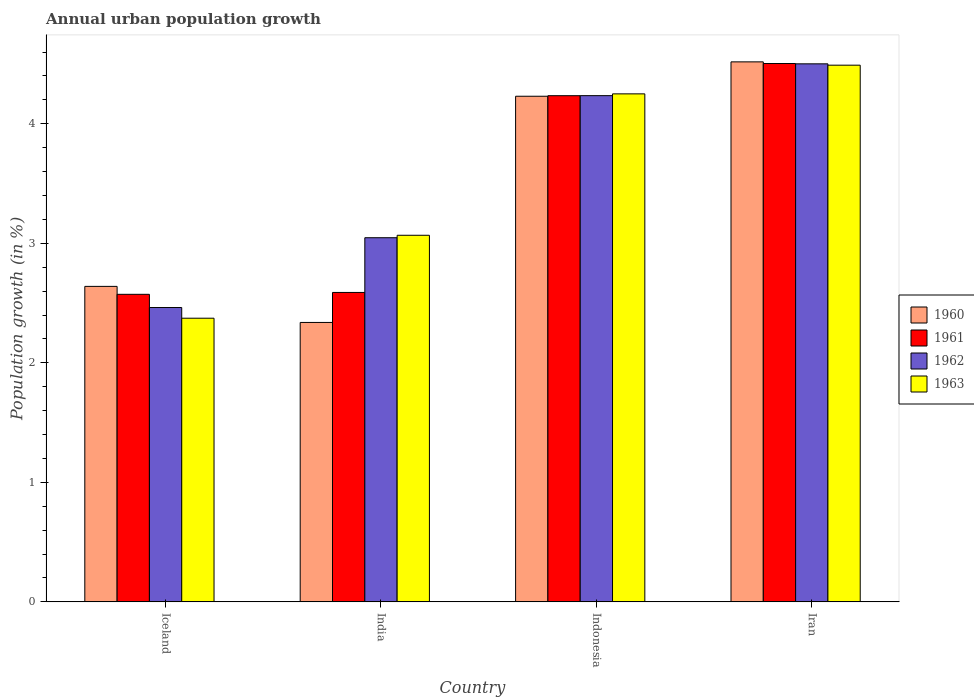How many groups of bars are there?
Your answer should be compact. 4. Are the number of bars on each tick of the X-axis equal?
Provide a short and direct response. Yes. In how many cases, is the number of bars for a given country not equal to the number of legend labels?
Keep it short and to the point. 0. What is the percentage of urban population growth in 1961 in Iceland?
Provide a succinct answer. 2.57. Across all countries, what is the maximum percentage of urban population growth in 1963?
Give a very brief answer. 4.49. Across all countries, what is the minimum percentage of urban population growth in 1962?
Give a very brief answer. 2.46. In which country was the percentage of urban population growth in 1962 maximum?
Provide a short and direct response. Iran. What is the total percentage of urban population growth in 1960 in the graph?
Your answer should be very brief. 13.73. What is the difference between the percentage of urban population growth in 1962 in Iceland and that in Iran?
Make the answer very short. -2.04. What is the difference between the percentage of urban population growth in 1961 in Iceland and the percentage of urban population growth in 1960 in Iran?
Make the answer very short. -1.94. What is the average percentage of urban population growth in 1960 per country?
Keep it short and to the point. 3.43. What is the difference between the percentage of urban population growth of/in 1962 and percentage of urban population growth of/in 1961 in Iceland?
Keep it short and to the point. -0.11. What is the ratio of the percentage of urban population growth in 1961 in Indonesia to that in Iran?
Keep it short and to the point. 0.94. Is the difference between the percentage of urban population growth in 1962 in India and Indonesia greater than the difference between the percentage of urban population growth in 1961 in India and Indonesia?
Make the answer very short. Yes. What is the difference between the highest and the second highest percentage of urban population growth in 1960?
Keep it short and to the point. -1.88. What is the difference between the highest and the lowest percentage of urban population growth in 1962?
Your response must be concise. 2.04. Is the sum of the percentage of urban population growth in 1963 in Iceland and Iran greater than the maximum percentage of urban population growth in 1961 across all countries?
Your answer should be compact. Yes. Is it the case that in every country, the sum of the percentage of urban population growth in 1963 and percentage of urban population growth in 1962 is greater than the sum of percentage of urban population growth in 1960 and percentage of urban population growth in 1961?
Your response must be concise. No. What does the 2nd bar from the left in Indonesia represents?
Offer a terse response. 1961. Is it the case that in every country, the sum of the percentage of urban population growth in 1963 and percentage of urban population growth in 1961 is greater than the percentage of urban population growth in 1960?
Your answer should be very brief. Yes. Are all the bars in the graph horizontal?
Make the answer very short. No. How many legend labels are there?
Make the answer very short. 4. How are the legend labels stacked?
Give a very brief answer. Vertical. What is the title of the graph?
Offer a terse response. Annual urban population growth. Does "1967" appear as one of the legend labels in the graph?
Ensure brevity in your answer.  No. What is the label or title of the Y-axis?
Make the answer very short. Population growth (in %). What is the Population growth (in %) in 1960 in Iceland?
Keep it short and to the point. 2.64. What is the Population growth (in %) in 1961 in Iceland?
Offer a very short reply. 2.57. What is the Population growth (in %) of 1962 in Iceland?
Ensure brevity in your answer.  2.46. What is the Population growth (in %) in 1963 in Iceland?
Provide a succinct answer. 2.37. What is the Population growth (in %) in 1960 in India?
Provide a succinct answer. 2.34. What is the Population growth (in %) in 1961 in India?
Ensure brevity in your answer.  2.59. What is the Population growth (in %) of 1962 in India?
Your response must be concise. 3.05. What is the Population growth (in %) of 1963 in India?
Your answer should be compact. 3.07. What is the Population growth (in %) in 1960 in Indonesia?
Your response must be concise. 4.23. What is the Population growth (in %) in 1961 in Indonesia?
Your answer should be very brief. 4.24. What is the Population growth (in %) of 1962 in Indonesia?
Make the answer very short. 4.24. What is the Population growth (in %) in 1963 in Indonesia?
Provide a short and direct response. 4.25. What is the Population growth (in %) of 1960 in Iran?
Ensure brevity in your answer.  4.52. What is the Population growth (in %) of 1961 in Iran?
Your response must be concise. 4.5. What is the Population growth (in %) of 1962 in Iran?
Offer a terse response. 4.5. What is the Population growth (in %) of 1963 in Iran?
Give a very brief answer. 4.49. Across all countries, what is the maximum Population growth (in %) of 1960?
Keep it short and to the point. 4.52. Across all countries, what is the maximum Population growth (in %) in 1961?
Make the answer very short. 4.5. Across all countries, what is the maximum Population growth (in %) of 1962?
Offer a terse response. 4.5. Across all countries, what is the maximum Population growth (in %) of 1963?
Keep it short and to the point. 4.49. Across all countries, what is the minimum Population growth (in %) of 1960?
Keep it short and to the point. 2.34. Across all countries, what is the minimum Population growth (in %) in 1961?
Your answer should be very brief. 2.57. Across all countries, what is the minimum Population growth (in %) of 1962?
Give a very brief answer. 2.46. Across all countries, what is the minimum Population growth (in %) in 1963?
Give a very brief answer. 2.37. What is the total Population growth (in %) in 1960 in the graph?
Give a very brief answer. 13.73. What is the total Population growth (in %) of 1961 in the graph?
Keep it short and to the point. 13.9. What is the total Population growth (in %) in 1962 in the graph?
Make the answer very short. 14.25. What is the total Population growth (in %) in 1963 in the graph?
Provide a short and direct response. 14.18. What is the difference between the Population growth (in %) in 1960 in Iceland and that in India?
Offer a very short reply. 0.3. What is the difference between the Population growth (in %) of 1961 in Iceland and that in India?
Give a very brief answer. -0.02. What is the difference between the Population growth (in %) in 1962 in Iceland and that in India?
Your answer should be compact. -0.58. What is the difference between the Population growth (in %) in 1963 in Iceland and that in India?
Ensure brevity in your answer.  -0.69. What is the difference between the Population growth (in %) in 1960 in Iceland and that in Indonesia?
Ensure brevity in your answer.  -1.59. What is the difference between the Population growth (in %) in 1961 in Iceland and that in Indonesia?
Make the answer very short. -1.66. What is the difference between the Population growth (in %) of 1962 in Iceland and that in Indonesia?
Your answer should be compact. -1.77. What is the difference between the Population growth (in %) of 1963 in Iceland and that in Indonesia?
Provide a short and direct response. -1.88. What is the difference between the Population growth (in %) in 1960 in Iceland and that in Iran?
Make the answer very short. -1.88. What is the difference between the Population growth (in %) of 1961 in Iceland and that in Iran?
Ensure brevity in your answer.  -1.93. What is the difference between the Population growth (in %) of 1962 in Iceland and that in Iran?
Keep it short and to the point. -2.04. What is the difference between the Population growth (in %) in 1963 in Iceland and that in Iran?
Provide a succinct answer. -2.12. What is the difference between the Population growth (in %) of 1960 in India and that in Indonesia?
Give a very brief answer. -1.89. What is the difference between the Population growth (in %) of 1961 in India and that in Indonesia?
Offer a very short reply. -1.65. What is the difference between the Population growth (in %) in 1962 in India and that in Indonesia?
Provide a short and direct response. -1.19. What is the difference between the Population growth (in %) of 1963 in India and that in Indonesia?
Provide a short and direct response. -1.18. What is the difference between the Population growth (in %) of 1960 in India and that in Iran?
Give a very brief answer. -2.18. What is the difference between the Population growth (in %) of 1961 in India and that in Iran?
Your answer should be very brief. -1.92. What is the difference between the Population growth (in %) in 1962 in India and that in Iran?
Keep it short and to the point. -1.45. What is the difference between the Population growth (in %) of 1963 in India and that in Iran?
Offer a very short reply. -1.42. What is the difference between the Population growth (in %) in 1960 in Indonesia and that in Iran?
Ensure brevity in your answer.  -0.29. What is the difference between the Population growth (in %) in 1961 in Indonesia and that in Iran?
Provide a short and direct response. -0.27. What is the difference between the Population growth (in %) in 1962 in Indonesia and that in Iran?
Offer a terse response. -0.27. What is the difference between the Population growth (in %) in 1963 in Indonesia and that in Iran?
Your answer should be compact. -0.24. What is the difference between the Population growth (in %) in 1960 in Iceland and the Population growth (in %) in 1961 in India?
Offer a very short reply. 0.05. What is the difference between the Population growth (in %) of 1960 in Iceland and the Population growth (in %) of 1962 in India?
Provide a succinct answer. -0.41. What is the difference between the Population growth (in %) of 1960 in Iceland and the Population growth (in %) of 1963 in India?
Make the answer very short. -0.43. What is the difference between the Population growth (in %) in 1961 in Iceland and the Population growth (in %) in 1962 in India?
Make the answer very short. -0.47. What is the difference between the Population growth (in %) in 1961 in Iceland and the Population growth (in %) in 1963 in India?
Provide a short and direct response. -0.49. What is the difference between the Population growth (in %) in 1962 in Iceland and the Population growth (in %) in 1963 in India?
Ensure brevity in your answer.  -0.6. What is the difference between the Population growth (in %) of 1960 in Iceland and the Population growth (in %) of 1961 in Indonesia?
Your answer should be very brief. -1.6. What is the difference between the Population growth (in %) of 1960 in Iceland and the Population growth (in %) of 1962 in Indonesia?
Your answer should be compact. -1.6. What is the difference between the Population growth (in %) of 1960 in Iceland and the Population growth (in %) of 1963 in Indonesia?
Provide a succinct answer. -1.61. What is the difference between the Population growth (in %) in 1961 in Iceland and the Population growth (in %) in 1962 in Indonesia?
Give a very brief answer. -1.66. What is the difference between the Population growth (in %) of 1961 in Iceland and the Population growth (in %) of 1963 in Indonesia?
Ensure brevity in your answer.  -1.68. What is the difference between the Population growth (in %) in 1962 in Iceland and the Population growth (in %) in 1963 in Indonesia?
Make the answer very short. -1.79. What is the difference between the Population growth (in %) of 1960 in Iceland and the Population growth (in %) of 1961 in Iran?
Your response must be concise. -1.86. What is the difference between the Population growth (in %) of 1960 in Iceland and the Population growth (in %) of 1962 in Iran?
Your answer should be very brief. -1.86. What is the difference between the Population growth (in %) in 1960 in Iceland and the Population growth (in %) in 1963 in Iran?
Provide a short and direct response. -1.85. What is the difference between the Population growth (in %) of 1961 in Iceland and the Population growth (in %) of 1962 in Iran?
Make the answer very short. -1.93. What is the difference between the Population growth (in %) of 1961 in Iceland and the Population growth (in %) of 1963 in Iran?
Give a very brief answer. -1.92. What is the difference between the Population growth (in %) of 1962 in Iceland and the Population growth (in %) of 1963 in Iran?
Ensure brevity in your answer.  -2.03. What is the difference between the Population growth (in %) in 1960 in India and the Population growth (in %) in 1961 in Indonesia?
Offer a terse response. -1.9. What is the difference between the Population growth (in %) in 1960 in India and the Population growth (in %) in 1962 in Indonesia?
Your answer should be compact. -1.9. What is the difference between the Population growth (in %) of 1960 in India and the Population growth (in %) of 1963 in Indonesia?
Offer a terse response. -1.91. What is the difference between the Population growth (in %) in 1961 in India and the Population growth (in %) in 1962 in Indonesia?
Ensure brevity in your answer.  -1.65. What is the difference between the Population growth (in %) in 1961 in India and the Population growth (in %) in 1963 in Indonesia?
Your answer should be compact. -1.66. What is the difference between the Population growth (in %) of 1962 in India and the Population growth (in %) of 1963 in Indonesia?
Your response must be concise. -1.2. What is the difference between the Population growth (in %) of 1960 in India and the Population growth (in %) of 1961 in Iran?
Offer a terse response. -2.17. What is the difference between the Population growth (in %) in 1960 in India and the Population growth (in %) in 1962 in Iran?
Offer a terse response. -2.16. What is the difference between the Population growth (in %) in 1960 in India and the Population growth (in %) in 1963 in Iran?
Offer a terse response. -2.15. What is the difference between the Population growth (in %) in 1961 in India and the Population growth (in %) in 1962 in Iran?
Provide a short and direct response. -1.91. What is the difference between the Population growth (in %) of 1961 in India and the Population growth (in %) of 1963 in Iran?
Your answer should be very brief. -1.9. What is the difference between the Population growth (in %) in 1962 in India and the Population growth (in %) in 1963 in Iran?
Offer a terse response. -1.44. What is the difference between the Population growth (in %) of 1960 in Indonesia and the Population growth (in %) of 1961 in Iran?
Your response must be concise. -0.27. What is the difference between the Population growth (in %) in 1960 in Indonesia and the Population growth (in %) in 1962 in Iran?
Ensure brevity in your answer.  -0.27. What is the difference between the Population growth (in %) of 1960 in Indonesia and the Population growth (in %) of 1963 in Iran?
Your answer should be very brief. -0.26. What is the difference between the Population growth (in %) in 1961 in Indonesia and the Population growth (in %) in 1962 in Iran?
Offer a terse response. -0.27. What is the difference between the Population growth (in %) of 1961 in Indonesia and the Population growth (in %) of 1963 in Iran?
Provide a succinct answer. -0.26. What is the difference between the Population growth (in %) of 1962 in Indonesia and the Population growth (in %) of 1963 in Iran?
Your answer should be very brief. -0.25. What is the average Population growth (in %) in 1960 per country?
Offer a terse response. 3.43. What is the average Population growth (in %) in 1961 per country?
Offer a very short reply. 3.48. What is the average Population growth (in %) of 1962 per country?
Your answer should be compact. 3.56. What is the average Population growth (in %) in 1963 per country?
Make the answer very short. 3.55. What is the difference between the Population growth (in %) of 1960 and Population growth (in %) of 1961 in Iceland?
Keep it short and to the point. 0.07. What is the difference between the Population growth (in %) in 1960 and Population growth (in %) in 1962 in Iceland?
Offer a terse response. 0.18. What is the difference between the Population growth (in %) of 1960 and Population growth (in %) of 1963 in Iceland?
Provide a succinct answer. 0.27. What is the difference between the Population growth (in %) of 1961 and Population growth (in %) of 1962 in Iceland?
Your answer should be very brief. 0.11. What is the difference between the Population growth (in %) of 1961 and Population growth (in %) of 1963 in Iceland?
Make the answer very short. 0.2. What is the difference between the Population growth (in %) in 1962 and Population growth (in %) in 1963 in Iceland?
Offer a very short reply. 0.09. What is the difference between the Population growth (in %) in 1960 and Population growth (in %) in 1961 in India?
Offer a terse response. -0.25. What is the difference between the Population growth (in %) in 1960 and Population growth (in %) in 1962 in India?
Your answer should be very brief. -0.71. What is the difference between the Population growth (in %) of 1960 and Population growth (in %) of 1963 in India?
Your answer should be compact. -0.73. What is the difference between the Population growth (in %) of 1961 and Population growth (in %) of 1962 in India?
Give a very brief answer. -0.46. What is the difference between the Population growth (in %) in 1961 and Population growth (in %) in 1963 in India?
Keep it short and to the point. -0.48. What is the difference between the Population growth (in %) in 1962 and Population growth (in %) in 1963 in India?
Make the answer very short. -0.02. What is the difference between the Population growth (in %) of 1960 and Population growth (in %) of 1961 in Indonesia?
Your answer should be very brief. -0. What is the difference between the Population growth (in %) of 1960 and Population growth (in %) of 1962 in Indonesia?
Provide a short and direct response. -0. What is the difference between the Population growth (in %) of 1960 and Population growth (in %) of 1963 in Indonesia?
Keep it short and to the point. -0.02. What is the difference between the Population growth (in %) in 1961 and Population growth (in %) in 1962 in Indonesia?
Ensure brevity in your answer.  -0. What is the difference between the Population growth (in %) in 1961 and Population growth (in %) in 1963 in Indonesia?
Your answer should be compact. -0.02. What is the difference between the Population growth (in %) in 1962 and Population growth (in %) in 1963 in Indonesia?
Your answer should be compact. -0.01. What is the difference between the Population growth (in %) in 1960 and Population growth (in %) in 1961 in Iran?
Provide a succinct answer. 0.01. What is the difference between the Population growth (in %) in 1960 and Population growth (in %) in 1962 in Iran?
Your answer should be very brief. 0.02. What is the difference between the Population growth (in %) in 1960 and Population growth (in %) in 1963 in Iran?
Offer a very short reply. 0.03. What is the difference between the Population growth (in %) of 1961 and Population growth (in %) of 1962 in Iran?
Make the answer very short. 0. What is the difference between the Population growth (in %) in 1961 and Population growth (in %) in 1963 in Iran?
Offer a very short reply. 0.01. What is the difference between the Population growth (in %) of 1962 and Population growth (in %) of 1963 in Iran?
Make the answer very short. 0.01. What is the ratio of the Population growth (in %) of 1960 in Iceland to that in India?
Your answer should be very brief. 1.13. What is the ratio of the Population growth (in %) in 1961 in Iceland to that in India?
Your response must be concise. 0.99. What is the ratio of the Population growth (in %) of 1962 in Iceland to that in India?
Your answer should be very brief. 0.81. What is the ratio of the Population growth (in %) in 1963 in Iceland to that in India?
Give a very brief answer. 0.77. What is the ratio of the Population growth (in %) of 1960 in Iceland to that in Indonesia?
Give a very brief answer. 0.62. What is the ratio of the Population growth (in %) in 1961 in Iceland to that in Indonesia?
Your answer should be very brief. 0.61. What is the ratio of the Population growth (in %) in 1962 in Iceland to that in Indonesia?
Keep it short and to the point. 0.58. What is the ratio of the Population growth (in %) of 1963 in Iceland to that in Indonesia?
Your response must be concise. 0.56. What is the ratio of the Population growth (in %) in 1960 in Iceland to that in Iran?
Offer a very short reply. 0.58. What is the ratio of the Population growth (in %) of 1961 in Iceland to that in Iran?
Offer a terse response. 0.57. What is the ratio of the Population growth (in %) of 1962 in Iceland to that in Iran?
Your answer should be very brief. 0.55. What is the ratio of the Population growth (in %) in 1963 in Iceland to that in Iran?
Ensure brevity in your answer.  0.53. What is the ratio of the Population growth (in %) of 1960 in India to that in Indonesia?
Give a very brief answer. 0.55. What is the ratio of the Population growth (in %) of 1961 in India to that in Indonesia?
Your answer should be compact. 0.61. What is the ratio of the Population growth (in %) of 1962 in India to that in Indonesia?
Offer a terse response. 0.72. What is the ratio of the Population growth (in %) of 1963 in India to that in Indonesia?
Ensure brevity in your answer.  0.72. What is the ratio of the Population growth (in %) of 1960 in India to that in Iran?
Ensure brevity in your answer.  0.52. What is the ratio of the Population growth (in %) in 1961 in India to that in Iran?
Your answer should be compact. 0.57. What is the ratio of the Population growth (in %) in 1962 in India to that in Iran?
Offer a very short reply. 0.68. What is the ratio of the Population growth (in %) in 1963 in India to that in Iran?
Make the answer very short. 0.68. What is the ratio of the Population growth (in %) of 1960 in Indonesia to that in Iran?
Ensure brevity in your answer.  0.94. What is the ratio of the Population growth (in %) in 1961 in Indonesia to that in Iran?
Keep it short and to the point. 0.94. What is the ratio of the Population growth (in %) of 1962 in Indonesia to that in Iran?
Ensure brevity in your answer.  0.94. What is the ratio of the Population growth (in %) in 1963 in Indonesia to that in Iran?
Keep it short and to the point. 0.95. What is the difference between the highest and the second highest Population growth (in %) in 1960?
Ensure brevity in your answer.  0.29. What is the difference between the highest and the second highest Population growth (in %) in 1961?
Give a very brief answer. 0.27. What is the difference between the highest and the second highest Population growth (in %) in 1962?
Keep it short and to the point. 0.27. What is the difference between the highest and the second highest Population growth (in %) of 1963?
Give a very brief answer. 0.24. What is the difference between the highest and the lowest Population growth (in %) in 1960?
Keep it short and to the point. 2.18. What is the difference between the highest and the lowest Population growth (in %) of 1961?
Make the answer very short. 1.93. What is the difference between the highest and the lowest Population growth (in %) of 1962?
Give a very brief answer. 2.04. What is the difference between the highest and the lowest Population growth (in %) in 1963?
Provide a short and direct response. 2.12. 